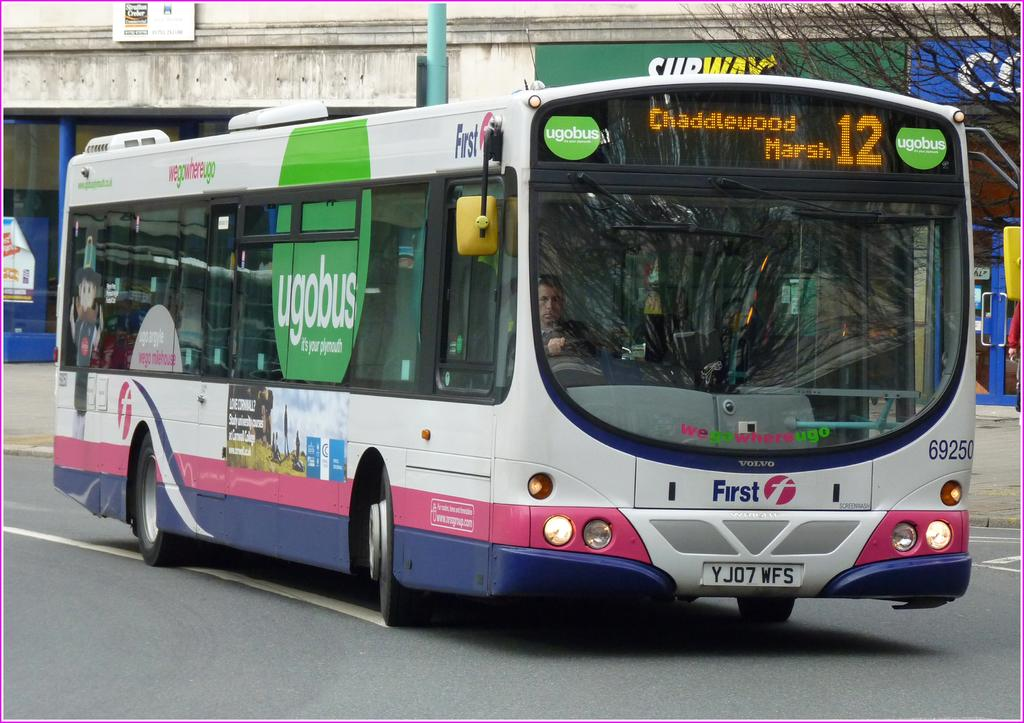What is the main subject of the image? The main subject of the image is a bus. Where is the bus located in the image? The bus is on the road in the image. Can you describe the interior of the bus? There is a driver in the driver seat inside the bus. What type of glove is the driver wearing while driving the bus in the image? There is no glove mentioned or visible in the image; the driver is not wearing any gloves. 